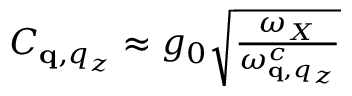<formula> <loc_0><loc_0><loc_500><loc_500>\begin{array} { r } { C _ { \mathbf q , q _ { z } } \approx g _ { 0 } \sqrt { \frac { \omega _ { X } } { \omega _ { \mathbf q , q _ { z } } ^ { c } } } } \end{array}</formula> 